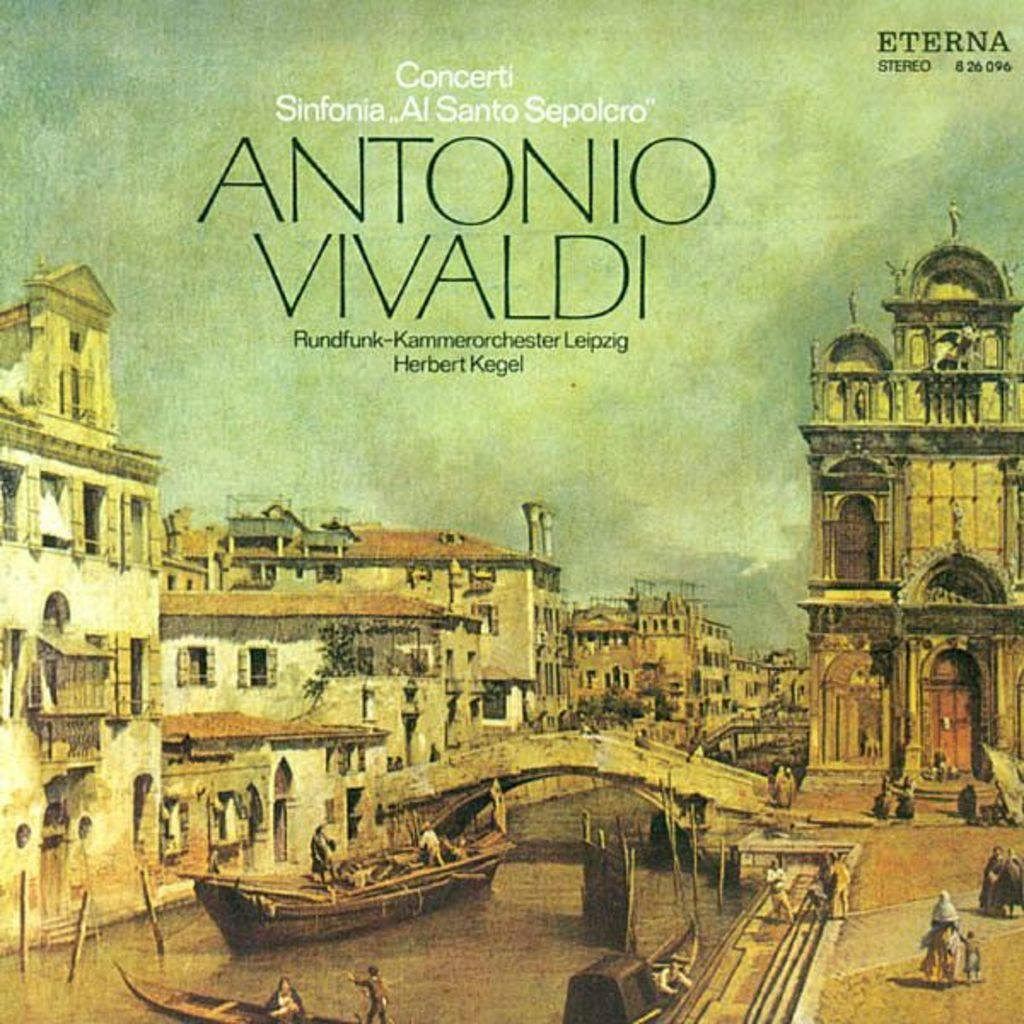<image>
Share a concise interpretation of the image provided. An album of Antonio Vivaldi with the cover showing an image of Venice. 